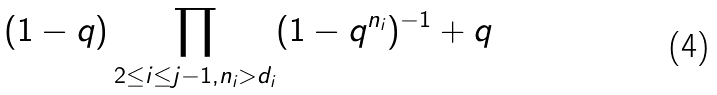<formula> <loc_0><loc_0><loc_500><loc_500>( 1 - q ) \prod _ { 2 \leq i \leq j - 1 , n _ { i } > d _ { i } } ( 1 - q ^ { n _ { i } } ) ^ { - 1 } + q</formula> 